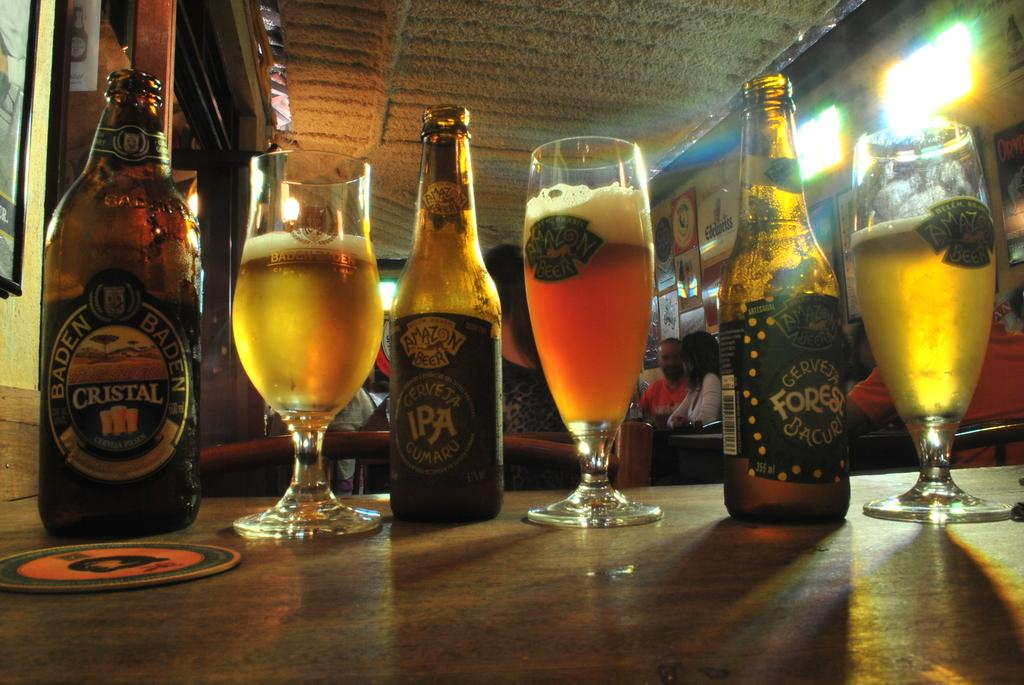<image>
Render a clear and concise summary of the photo. 3 glass bottles of drinks such as Baden Baden Crystal 